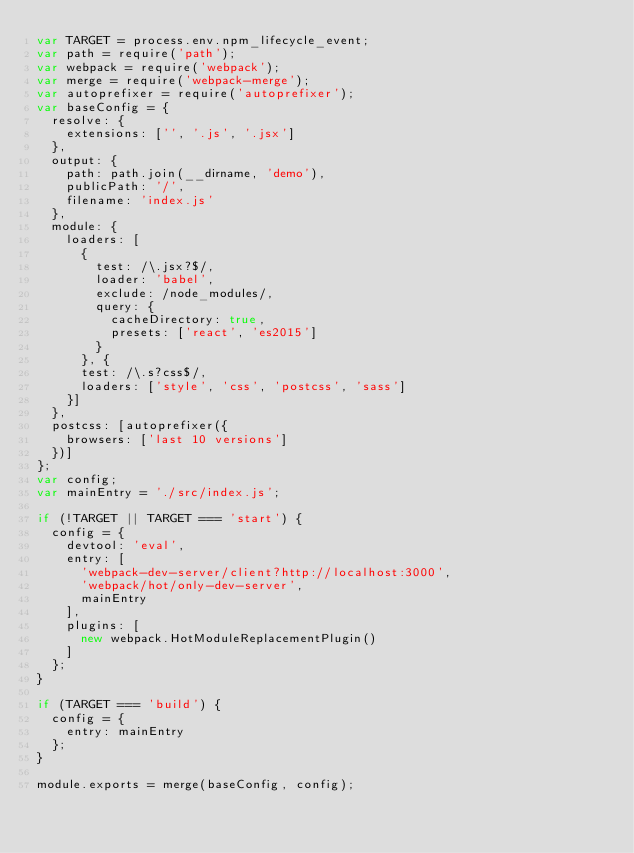Convert code to text. <code><loc_0><loc_0><loc_500><loc_500><_JavaScript_>var TARGET = process.env.npm_lifecycle_event;
var path = require('path');
var webpack = require('webpack');
var merge = require('webpack-merge');
var autoprefixer = require('autoprefixer');
var baseConfig = {
  resolve: {
    extensions: ['', '.js', '.jsx']
  },
  output: {
    path: path.join(__dirname, 'demo'),
    publicPath: '/',
    filename: 'index.js'
  },
  module: {
    loaders: [
      {
        test: /\.jsx?$/,
        loader: 'babel',
        exclude: /node_modules/,
        query: {
          cacheDirectory: true,
          presets: ['react', 'es2015']
        }
      }, {
      test: /\.s?css$/,
      loaders: ['style', 'css', 'postcss', 'sass']
    }]
  },
  postcss: [autoprefixer({
    browsers: ['last 10 versions']
  })]
};
var config;
var mainEntry = './src/index.js';

if (!TARGET || TARGET === 'start') {
  config = {
    devtool: 'eval',
    entry: [
      'webpack-dev-server/client?http://localhost:3000',
      'webpack/hot/only-dev-server',
      mainEntry
    ],
    plugins: [
      new webpack.HotModuleReplacementPlugin()
    ]
  };
}

if (TARGET === 'build') {
  config = {
    entry: mainEntry
  };
}

module.exports = merge(baseConfig, config);
</code> 